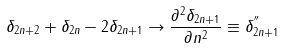<formula> <loc_0><loc_0><loc_500><loc_500>\delta _ { 2 n + 2 } + \delta _ { 2 n } - 2 \delta _ { 2 n + 1 } \rightarrow \frac { \partial ^ { 2 } \delta _ { 2 n + 1 } } { \partial n ^ { 2 } } \equiv \delta _ { 2 n + 1 } ^ { ^ { \prime \prime } }</formula> 